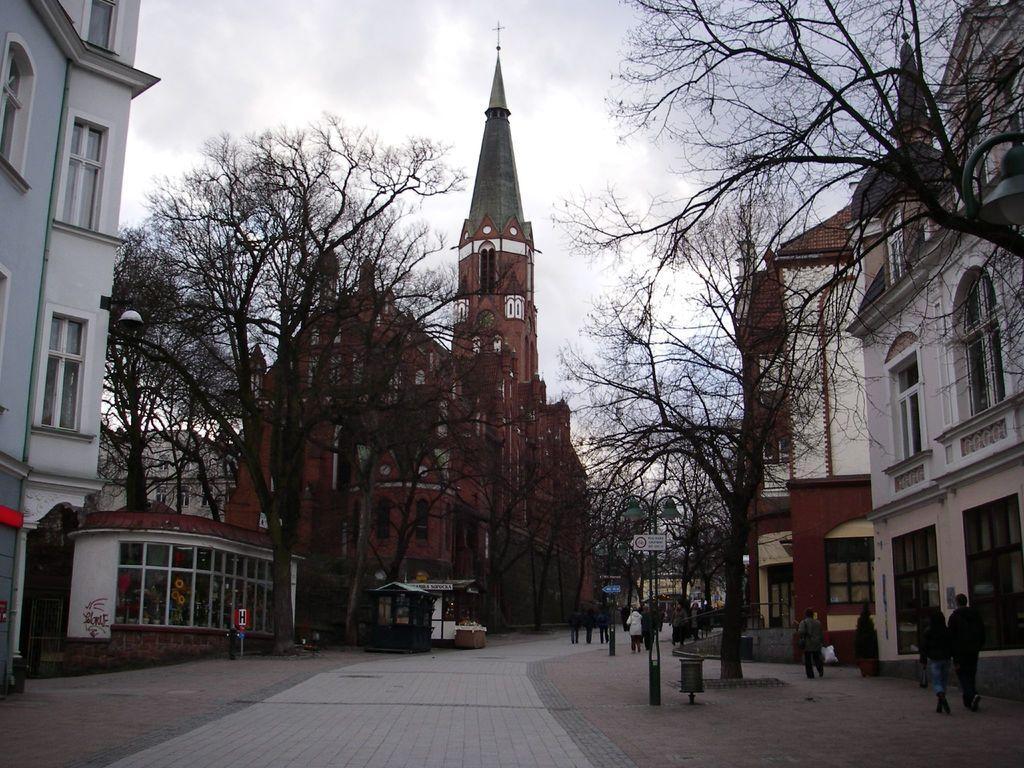Please provide a concise description of this image. These are the buildings with the windows and glass doors. This looks like a pathway. I can see the trees. There are groups of people walking. Here is the sky. This is a spire with a holy cross symbol, which is at the top of a building. This looks like a small booth. I can see a board, which is attached to a pole. 